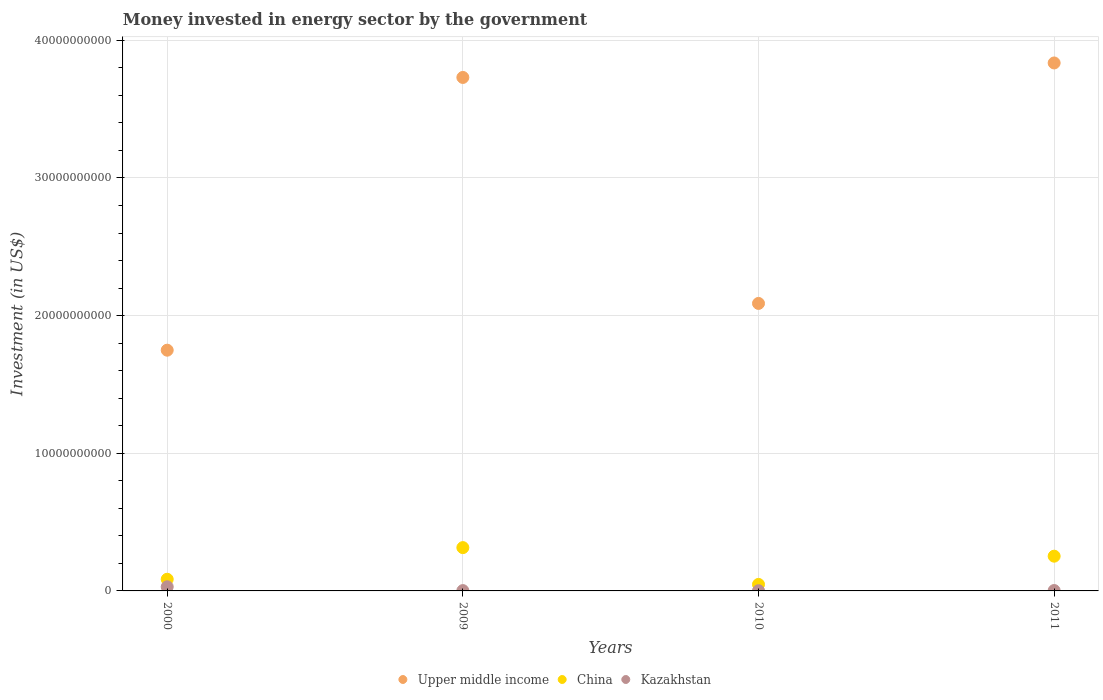Is the number of dotlines equal to the number of legend labels?
Your answer should be very brief. Yes. What is the money spent in energy sector in Kazakhstan in 2010?
Provide a short and direct response. 1.45e+07. Across all years, what is the maximum money spent in energy sector in China?
Provide a succinct answer. 3.15e+09. Across all years, what is the minimum money spent in energy sector in Kazakhstan?
Offer a terse response. 1.45e+07. In which year was the money spent in energy sector in Kazakhstan maximum?
Give a very brief answer. 2000. What is the total money spent in energy sector in China in the graph?
Provide a short and direct response. 6.99e+09. What is the difference between the money spent in energy sector in Upper middle income in 2000 and that in 2010?
Offer a very short reply. -3.40e+09. What is the difference between the money spent in energy sector in China in 2000 and the money spent in energy sector in Kazakhstan in 2009?
Keep it short and to the point. 8.24e+08. What is the average money spent in energy sector in Kazakhstan per year?
Provide a succinct answer. 9.14e+07. In the year 2011, what is the difference between the money spent in energy sector in China and money spent in energy sector in Kazakhstan?
Offer a very short reply. 2.50e+09. What is the ratio of the money spent in energy sector in Upper middle income in 2000 to that in 2009?
Offer a terse response. 0.47. Is the money spent in energy sector in Upper middle income in 2009 less than that in 2010?
Your response must be concise. No. What is the difference between the highest and the second highest money spent in energy sector in China?
Offer a terse response. 6.22e+08. What is the difference between the highest and the lowest money spent in energy sector in Upper middle income?
Your response must be concise. 2.09e+1. In how many years, is the money spent in energy sector in China greater than the average money spent in energy sector in China taken over all years?
Provide a succinct answer. 2. Is the sum of the money spent in energy sector in China in 2009 and 2010 greater than the maximum money spent in energy sector in Upper middle income across all years?
Keep it short and to the point. No. Does the money spent in energy sector in Kazakhstan monotonically increase over the years?
Offer a very short reply. No. Is the money spent in energy sector in China strictly greater than the money spent in energy sector in Kazakhstan over the years?
Your answer should be compact. Yes. Is the money spent in energy sector in Kazakhstan strictly less than the money spent in energy sector in China over the years?
Provide a short and direct response. Yes. How many dotlines are there?
Ensure brevity in your answer.  3. How many years are there in the graph?
Ensure brevity in your answer.  4. Are the values on the major ticks of Y-axis written in scientific E-notation?
Your response must be concise. No. Where does the legend appear in the graph?
Ensure brevity in your answer.  Bottom center. How many legend labels are there?
Offer a terse response. 3. How are the legend labels stacked?
Give a very brief answer. Horizontal. What is the title of the graph?
Provide a short and direct response. Money invested in energy sector by the government. What is the label or title of the X-axis?
Offer a terse response. Years. What is the label or title of the Y-axis?
Your answer should be very brief. Investment (in US$). What is the Investment (in US$) in Upper middle income in 2000?
Ensure brevity in your answer.  1.75e+1. What is the Investment (in US$) of China in 2000?
Your answer should be very brief. 8.47e+08. What is the Investment (in US$) of Kazakhstan in 2000?
Provide a succinct answer. 3.00e+08. What is the Investment (in US$) of Upper middle income in 2009?
Provide a short and direct response. 3.73e+1. What is the Investment (in US$) of China in 2009?
Your answer should be compact. 3.15e+09. What is the Investment (in US$) of Kazakhstan in 2009?
Your answer should be very brief. 2.30e+07. What is the Investment (in US$) in Upper middle income in 2010?
Offer a very short reply. 2.09e+1. What is the Investment (in US$) of China in 2010?
Provide a succinct answer. 4.73e+08. What is the Investment (in US$) in Kazakhstan in 2010?
Your answer should be very brief. 1.45e+07. What is the Investment (in US$) of Upper middle income in 2011?
Make the answer very short. 3.84e+1. What is the Investment (in US$) in China in 2011?
Offer a terse response. 2.52e+09. What is the Investment (in US$) of Kazakhstan in 2011?
Ensure brevity in your answer.  2.82e+07. Across all years, what is the maximum Investment (in US$) in Upper middle income?
Provide a succinct answer. 3.84e+1. Across all years, what is the maximum Investment (in US$) in China?
Provide a short and direct response. 3.15e+09. Across all years, what is the maximum Investment (in US$) of Kazakhstan?
Your response must be concise. 3.00e+08. Across all years, what is the minimum Investment (in US$) in Upper middle income?
Provide a short and direct response. 1.75e+1. Across all years, what is the minimum Investment (in US$) of China?
Your answer should be very brief. 4.73e+08. Across all years, what is the minimum Investment (in US$) of Kazakhstan?
Your answer should be very brief. 1.45e+07. What is the total Investment (in US$) of Upper middle income in the graph?
Offer a terse response. 1.14e+11. What is the total Investment (in US$) in China in the graph?
Provide a succinct answer. 6.99e+09. What is the total Investment (in US$) in Kazakhstan in the graph?
Give a very brief answer. 3.66e+08. What is the difference between the Investment (in US$) of Upper middle income in 2000 and that in 2009?
Offer a very short reply. -1.98e+1. What is the difference between the Investment (in US$) in China in 2000 and that in 2009?
Your answer should be very brief. -2.30e+09. What is the difference between the Investment (in US$) of Kazakhstan in 2000 and that in 2009?
Give a very brief answer. 2.77e+08. What is the difference between the Investment (in US$) of Upper middle income in 2000 and that in 2010?
Your answer should be compact. -3.40e+09. What is the difference between the Investment (in US$) in China in 2000 and that in 2010?
Provide a succinct answer. 3.74e+08. What is the difference between the Investment (in US$) in Kazakhstan in 2000 and that in 2010?
Offer a terse response. 2.86e+08. What is the difference between the Investment (in US$) of Upper middle income in 2000 and that in 2011?
Your answer should be compact. -2.09e+1. What is the difference between the Investment (in US$) of China in 2000 and that in 2011?
Offer a terse response. -1.68e+09. What is the difference between the Investment (in US$) of Kazakhstan in 2000 and that in 2011?
Your answer should be very brief. 2.72e+08. What is the difference between the Investment (in US$) in Upper middle income in 2009 and that in 2010?
Your answer should be very brief. 1.64e+1. What is the difference between the Investment (in US$) of China in 2009 and that in 2010?
Ensure brevity in your answer.  2.67e+09. What is the difference between the Investment (in US$) in Kazakhstan in 2009 and that in 2010?
Make the answer very short. 8.50e+06. What is the difference between the Investment (in US$) of Upper middle income in 2009 and that in 2011?
Your response must be concise. -1.05e+09. What is the difference between the Investment (in US$) of China in 2009 and that in 2011?
Give a very brief answer. 6.22e+08. What is the difference between the Investment (in US$) of Kazakhstan in 2009 and that in 2011?
Give a very brief answer. -5.20e+06. What is the difference between the Investment (in US$) in Upper middle income in 2010 and that in 2011?
Provide a succinct answer. -1.75e+1. What is the difference between the Investment (in US$) in China in 2010 and that in 2011?
Make the answer very short. -2.05e+09. What is the difference between the Investment (in US$) of Kazakhstan in 2010 and that in 2011?
Make the answer very short. -1.37e+07. What is the difference between the Investment (in US$) in Upper middle income in 2000 and the Investment (in US$) in China in 2009?
Offer a terse response. 1.43e+1. What is the difference between the Investment (in US$) in Upper middle income in 2000 and the Investment (in US$) in Kazakhstan in 2009?
Your answer should be compact. 1.75e+1. What is the difference between the Investment (in US$) of China in 2000 and the Investment (in US$) of Kazakhstan in 2009?
Make the answer very short. 8.24e+08. What is the difference between the Investment (in US$) in Upper middle income in 2000 and the Investment (in US$) in China in 2010?
Your answer should be very brief. 1.70e+1. What is the difference between the Investment (in US$) in Upper middle income in 2000 and the Investment (in US$) in Kazakhstan in 2010?
Give a very brief answer. 1.75e+1. What is the difference between the Investment (in US$) of China in 2000 and the Investment (in US$) of Kazakhstan in 2010?
Provide a succinct answer. 8.32e+08. What is the difference between the Investment (in US$) of Upper middle income in 2000 and the Investment (in US$) of China in 2011?
Offer a very short reply. 1.50e+1. What is the difference between the Investment (in US$) in Upper middle income in 2000 and the Investment (in US$) in Kazakhstan in 2011?
Provide a short and direct response. 1.75e+1. What is the difference between the Investment (in US$) of China in 2000 and the Investment (in US$) of Kazakhstan in 2011?
Your answer should be compact. 8.19e+08. What is the difference between the Investment (in US$) of Upper middle income in 2009 and the Investment (in US$) of China in 2010?
Offer a terse response. 3.68e+1. What is the difference between the Investment (in US$) in Upper middle income in 2009 and the Investment (in US$) in Kazakhstan in 2010?
Your answer should be very brief. 3.73e+1. What is the difference between the Investment (in US$) of China in 2009 and the Investment (in US$) of Kazakhstan in 2010?
Give a very brief answer. 3.13e+09. What is the difference between the Investment (in US$) of Upper middle income in 2009 and the Investment (in US$) of China in 2011?
Your answer should be very brief. 3.48e+1. What is the difference between the Investment (in US$) of Upper middle income in 2009 and the Investment (in US$) of Kazakhstan in 2011?
Offer a terse response. 3.73e+1. What is the difference between the Investment (in US$) in China in 2009 and the Investment (in US$) in Kazakhstan in 2011?
Provide a short and direct response. 3.12e+09. What is the difference between the Investment (in US$) in Upper middle income in 2010 and the Investment (in US$) in China in 2011?
Provide a succinct answer. 1.84e+1. What is the difference between the Investment (in US$) of Upper middle income in 2010 and the Investment (in US$) of Kazakhstan in 2011?
Offer a terse response. 2.09e+1. What is the difference between the Investment (in US$) in China in 2010 and the Investment (in US$) in Kazakhstan in 2011?
Give a very brief answer. 4.45e+08. What is the average Investment (in US$) of Upper middle income per year?
Keep it short and to the point. 2.85e+1. What is the average Investment (in US$) in China per year?
Ensure brevity in your answer.  1.75e+09. What is the average Investment (in US$) in Kazakhstan per year?
Offer a very short reply. 9.14e+07. In the year 2000, what is the difference between the Investment (in US$) of Upper middle income and Investment (in US$) of China?
Your answer should be very brief. 1.66e+1. In the year 2000, what is the difference between the Investment (in US$) in Upper middle income and Investment (in US$) in Kazakhstan?
Provide a short and direct response. 1.72e+1. In the year 2000, what is the difference between the Investment (in US$) of China and Investment (in US$) of Kazakhstan?
Your answer should be compact. 5.47e+08. In the year 2009, what is the difference between the Investment (in US$) of Upper middle income and Investment (in US$) of China?
Your answer should be compact. 3.42e+1. In the year 2009, what is the difference between the Investment (in US$) of Upper middle income and Investment (in US$) of Kazakhstan?
Provide a short and direct response. 3.73e+1. In the year 2009, what is the difference between the Investment (in US$) of China and Investment (in US$) of Kazakhstan?
Your answer should be very brief. 3.12e+09. In the year 2010, what is the difference between the Investment (in US$) in Upper middle income and Investment (in US$) in China?
Ensure brevity in your answer.  2.04e+1. In the year 2010, what is the difference between the Investment (in US$) in Upper middle income and Investment (in US$) in Kazakhstan?
Your answer should be compact. 2.09e+1. In the year 2010, what is the difference between the Investment (in US$) in China and Investment (in US$) in Kazakhstan?
Give a very brief answer. 4.58e+08. In the year 2011, what is the difference between the Investment (in US$) in Upper middle income and Investment (in US$) in China?
Offer a terse response. 3.58e+1. In the year 2011, what is the difference between the Investment (in US$) in Upper middle income and Investment (in US$) in Kazakhstan?
Give a very brief answer. 3.83e+1. In the year 2011, what is the difference between the Investment (in US$) of China and Investment (in US$) of Kazakhstan?
Give a very brief answer. 2.50e+09. What is the ratio of the Investment (in US$) in Upper middle income in 2000 to that in 2009?
Provide a succinct answer. 0.47. What is the ratio of the Investment (in US$) of China in 2000 to that in 2009?
Ensure brevity in your answer.  0.27. What is the ratio of the Investment (in US$) of Kazakhstan in 2000 to that in 2009?
Offer a terse response. 13.04. What is the ratio of the Investment (in US$) of Upper middle income in 2000 to that in 2010?
Make the answer very short. 0.84. What is the ratio of the Investment (in US$) in China in 2000 to that in 2010?
Keep it short and to the point. 1.79. What is the ratio of the Investment (in US$) in Kazakhstan in 2000 to that in 2010?
Provide a succinct answer. 20.69. What is the ratio of the Investment (in US$) in Upper middle income in 2000 to that in 2011?
Offer a terse response. 0.46. What is the ratio of the Investment (in US$) in China in 2000 to that in 2011?
Your response must be concise. 0.34. What is the ratio of the Investment (in US$) of Kazakhstan in 2000 to that in 2011?
Your answer should be compact. 10.64. What is the ratio of the Investment (in US$) of Upper middle income in 2009 to that in 2010?
Provide a short and direct response. 1.79. What is the ratio of the Investment (in US$) in China in 2009 to that in 2010?
Your answer should be very brief. 6.65. What is the ratio of the Investment (in US$) in Kazakhstan in 2009 to that in 2010?
Your answer should be very brief. 1.59. What is the ratio of the Investment (in US$) in Upper middle income in 2009 to that in 2011?
Your response must be concise. 0.97. What is the ratio of the Investment (in US$) of China in 2009 to that in 2011?
Offer a terse response. 1.25. What is the ratio of the Investment (in US$) of Kazakhstan in 2009 to that in 2011?
Your response must be concise. 0.82. What is the ratio of the Investment (in US$) of Upper middle income in 2010 to that in 2011?
Provide a succinct answer. 0.54. What is the ratio of the Investment (in US$) of China in 2010 to that in 2011?
Keep it short and to the point. 0.19. What is the ratio of the Investment (in US$) in Kazakhstan in 2010 to that in 2011?
Ensure brevity in your answer.  0.51. What is the difference between the highest and the second highest Investment (in US$) in Upper middle income?
Your response must be concise. 1.05e+09. What is the difference between the highest and the second highest Investment (in US$) of China?
Give a very brief answer. 6.22e+08. What is the difference between the highest and the second highest Investment (in US$) of Kazakhstan?
Keep it short and to the point. 2.72e+08. What is the difference between the highest and the lowest Investment (in US$) of Upper middle income?
Offer a very short reply. 2.09e+1. What is the difference between the highest and the lowest Investment (in US$) in China?
Your answer should be compact. 2.67e+09. What is the difference between the highest and the lowest Investment (in US$) in Kazakhstan?
Give a very brief answer. 2.86e+08. 